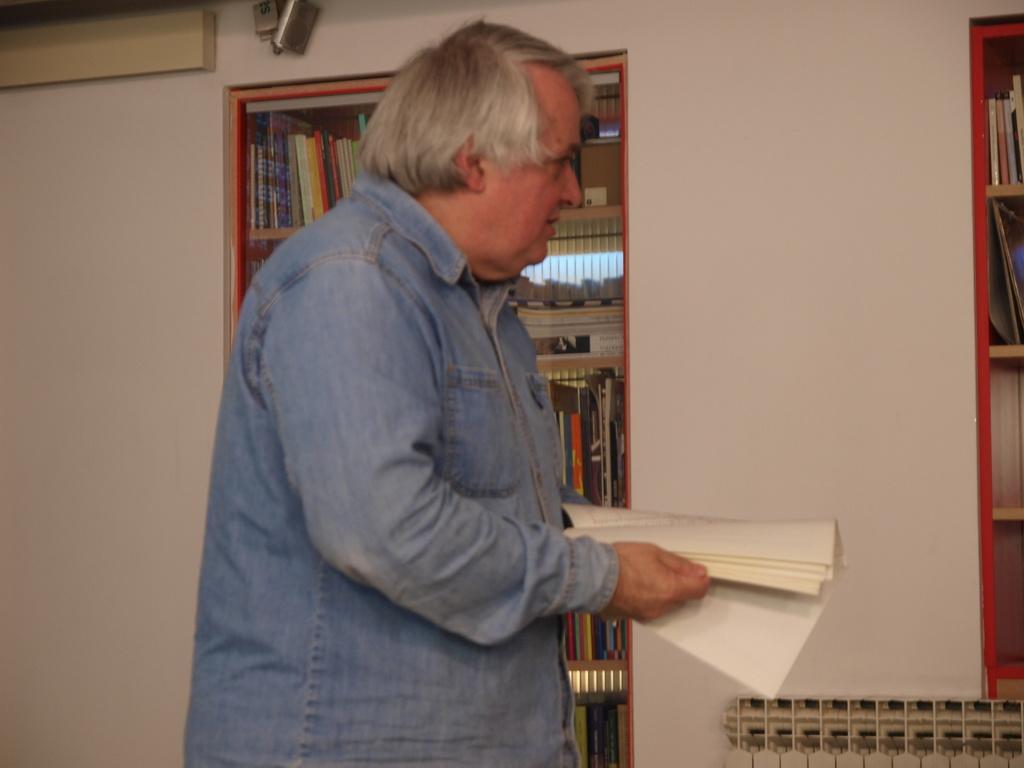Can you describe this image briefly? In this image I can see a man wearing a shirt, standing facing towards the right side and holding a book in the hands. In the background there is a wall and also I can see two racks which are filled with the books. 